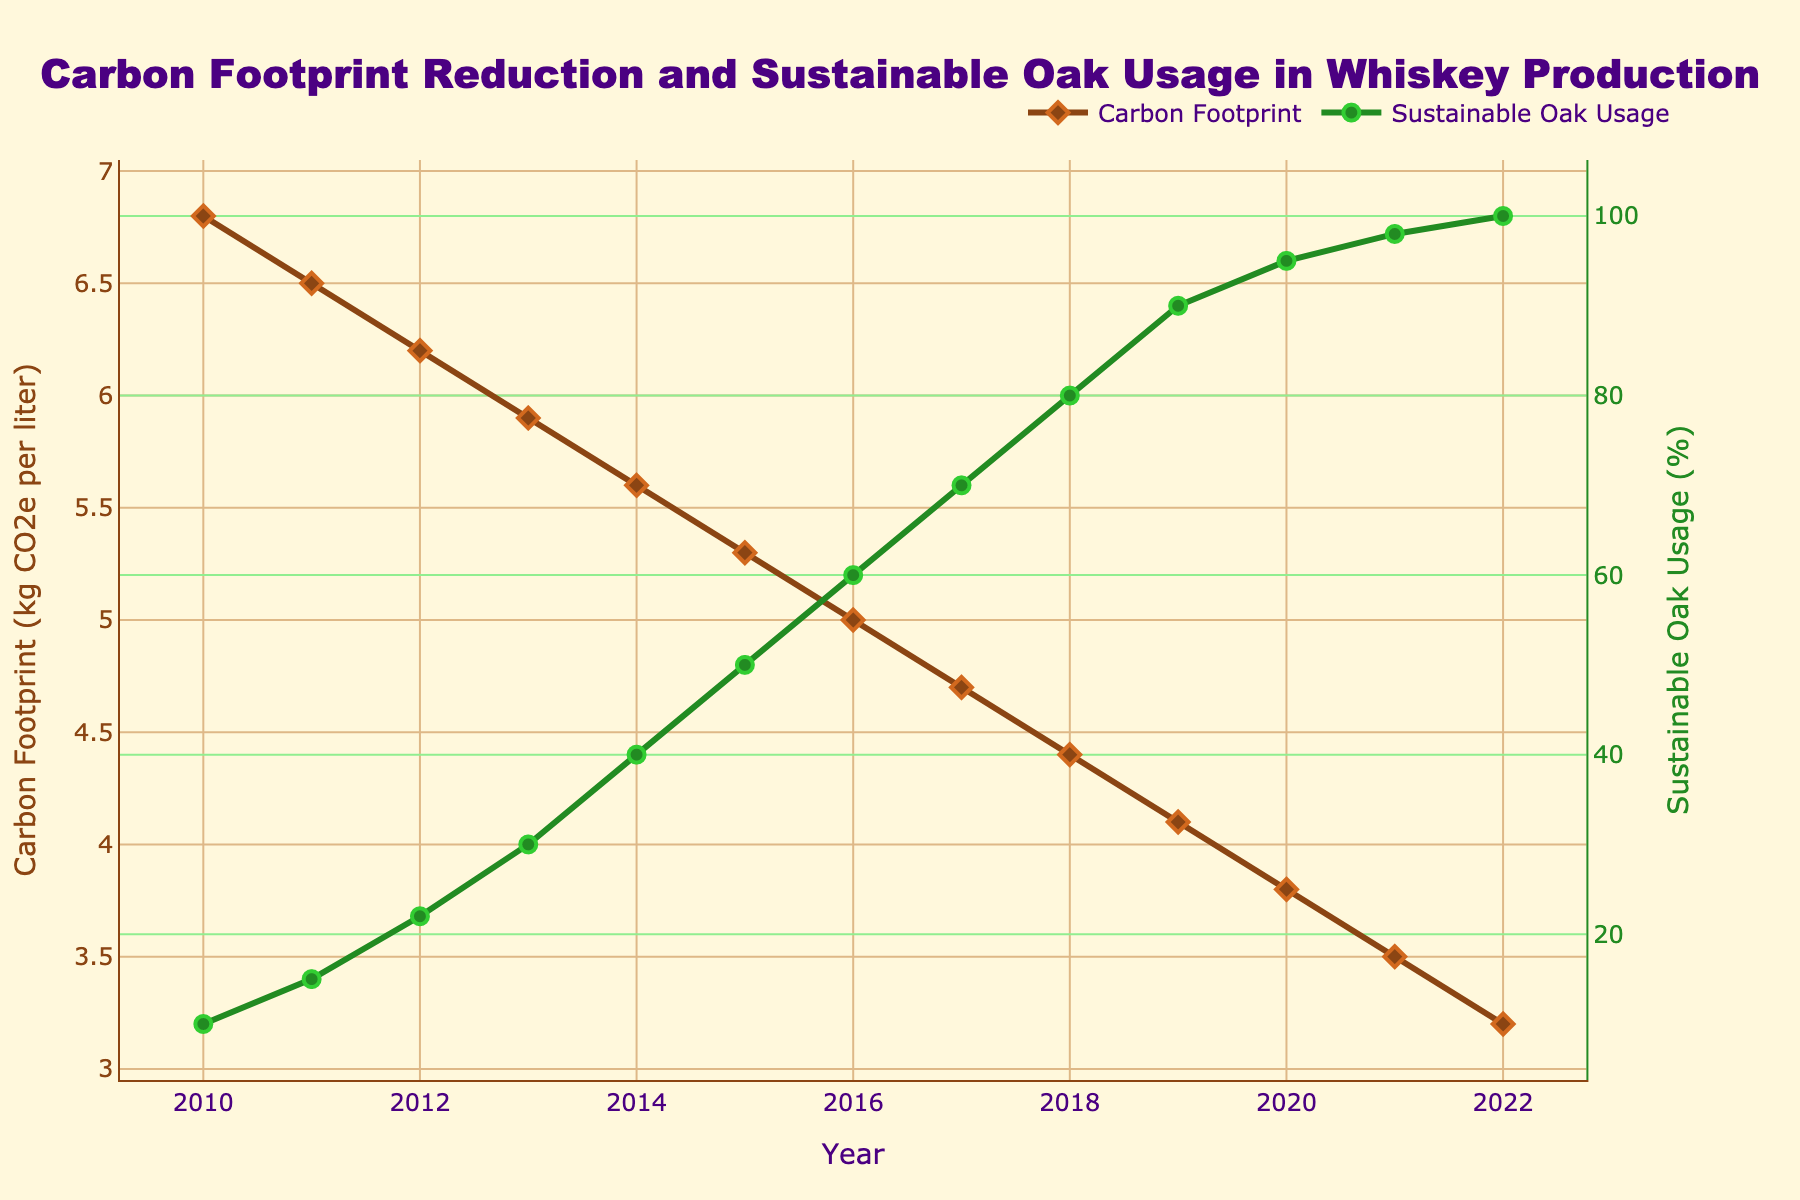What year did the Carbon Footprint first drop below 5 kg CO2e per liter? The Carbon Footprint dropped below 5 kg CO2e per liter in 2016, as can be seen where the Carbon Footprint line (brown) is below 5 on the y-axis.
Answer: 2016 How much did the Carbon Footprint decrease between 2012 and 2016? The Carbon Footprint in 2012 was 6.2 kg CO2e per liter and in 2016 it was 5.0 kg CO2e per liter. The decrease is 6.2 - 5.0 = 1.2 kg CO2e per liter.
Answer: 1.2 kg CO2e per liter What is the Carbon Footprint level when Sustainable Oak Usage reached 100%? When the Sustainable Oak Usage line (green) reached 100% on the secondary y-axis, the Carbon Footprint line (brown) corresponds to 3.2 kg CO2e per liter.
Answer: 3.2 kg CO2e per liter How did the Sustainable Oak Usage change from 2010 to 2022? In 2010, Sustainable Oak Usage was 10%. By 2022, it had increased to 100%. The change is 100% - 10% = 90%.
Answer: Increased by 90% What was the trend of the Carbon Footprint and Sustainable Oak Usage from 2010 to 2022? The Carbon Footprint showed a downward trend (decreasing) from 6.8 kg CO2e per liter to 3.2 kg CO2e per liter. Conversely, the Sustainable Oak Usage had an upward trend (increasing) from 10% to 100%.
Answer: Decreasing Carbon Footprint, Increasing Sustainable Oak Usage During which years did the Sustainable Oak Usage increase by the highest percentage? The Sustainable Oak Usage increased from 90% in 2019 to 95% in 2020, a 5 percentage point jump. This is the largest annual increase in the dataset.
Answer: 2019 to 2020 What is the difference in Carbon Footprint reduction between the start and end of the provided years? The Carbon Footprint was 6.8 kg CO2e per liter in 2010 and 3.2 kg CO2e per liter in 2022. The reduction is 6.8 - 3.2 = 3.6 kg CO2e per liter.
Answer: 3.6 kg CO2e per liter Compare the Sustainable Oak Usage in 2012 and 2022. How much did it increase? In 2012, Sustainable Oak Usage was 22%, and in 2022, it was 100%. The increase is 100% - 22% = 78%.
Answer: 78% Which year had the same amount of Carbon Footprint and Sustainable Oak Usage percentages? At no point do the Carbon Footprint in kg CO2e per liter and Sustainable Oak Usage percentages exactly match each other.
Answer: None What is the relationship between the Carbon Footprint and improvements in energy efficiency over the 12-year period? A detailed examination of the data shows that as energy efficiency improved (from 0% in 2010 to 40% in 2022), the Carbon Footprint consistently decreased. This suggests a negative correlation where improvements in energy efficiency contributed to Carbon Footprint reduction.
Answer: Negative correlation 